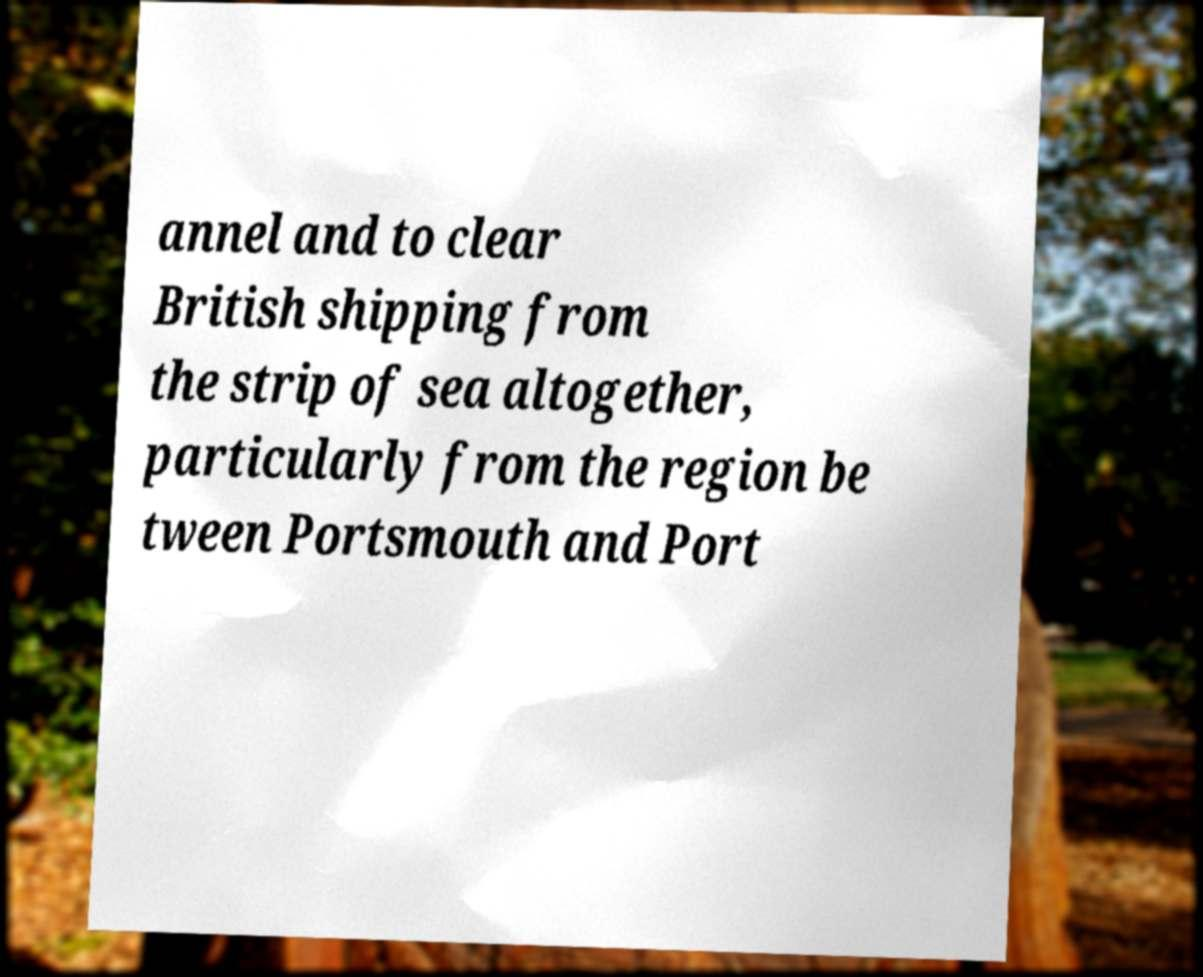Please identify and transcribe the text found in this image. annel and to clear British shipping from the strip of sea altogether, particularly from the region be tween Portsmouth and Port 